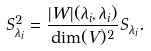Convert formula to latex. <formula><loc_0><loc_0><loc_500><loc_500>S ^ { 2 } _ { \lambda _ { i } } = \frac { | W | ( \lambda _ { i } , \lambda _ { i } ) } { \dim ( V ) ^ { 2 } } S _ { \lambda _ { i } } .</formula> 